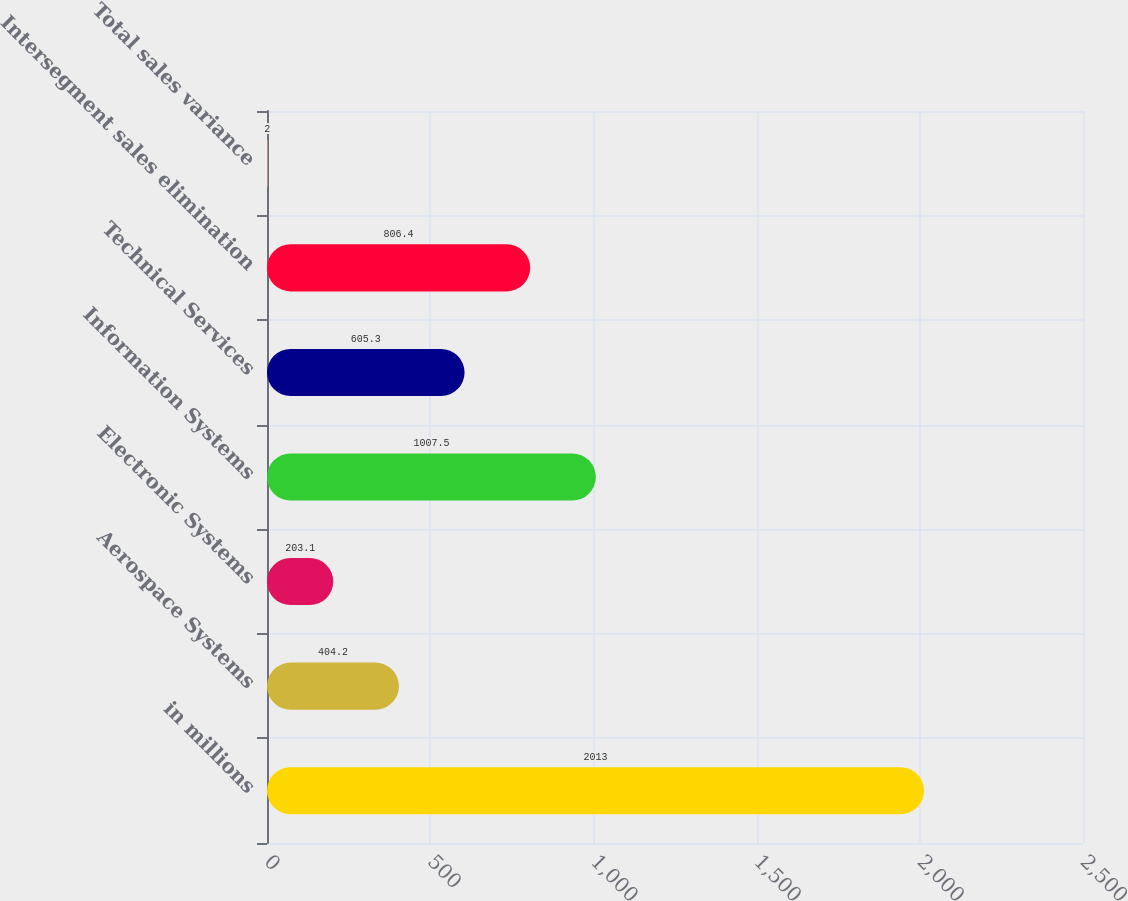Convert chart to OTSL. <chart><loc_0><loc_0><loc_500><loc_500><bar_chart><fcel>in millions<fcel>Aerospace Systems<fcel>Electronic Systems<fcel>Information Systems<fcel>Technical Services<fcel>Intersegment sales elimination<fcel>Total sales variance<nl><fcel>2013<fcel>404.2<fcel>203.1<fcel>1007.5<fcel>605.3<fcel>806.4<fcel>2<nl></chart> 